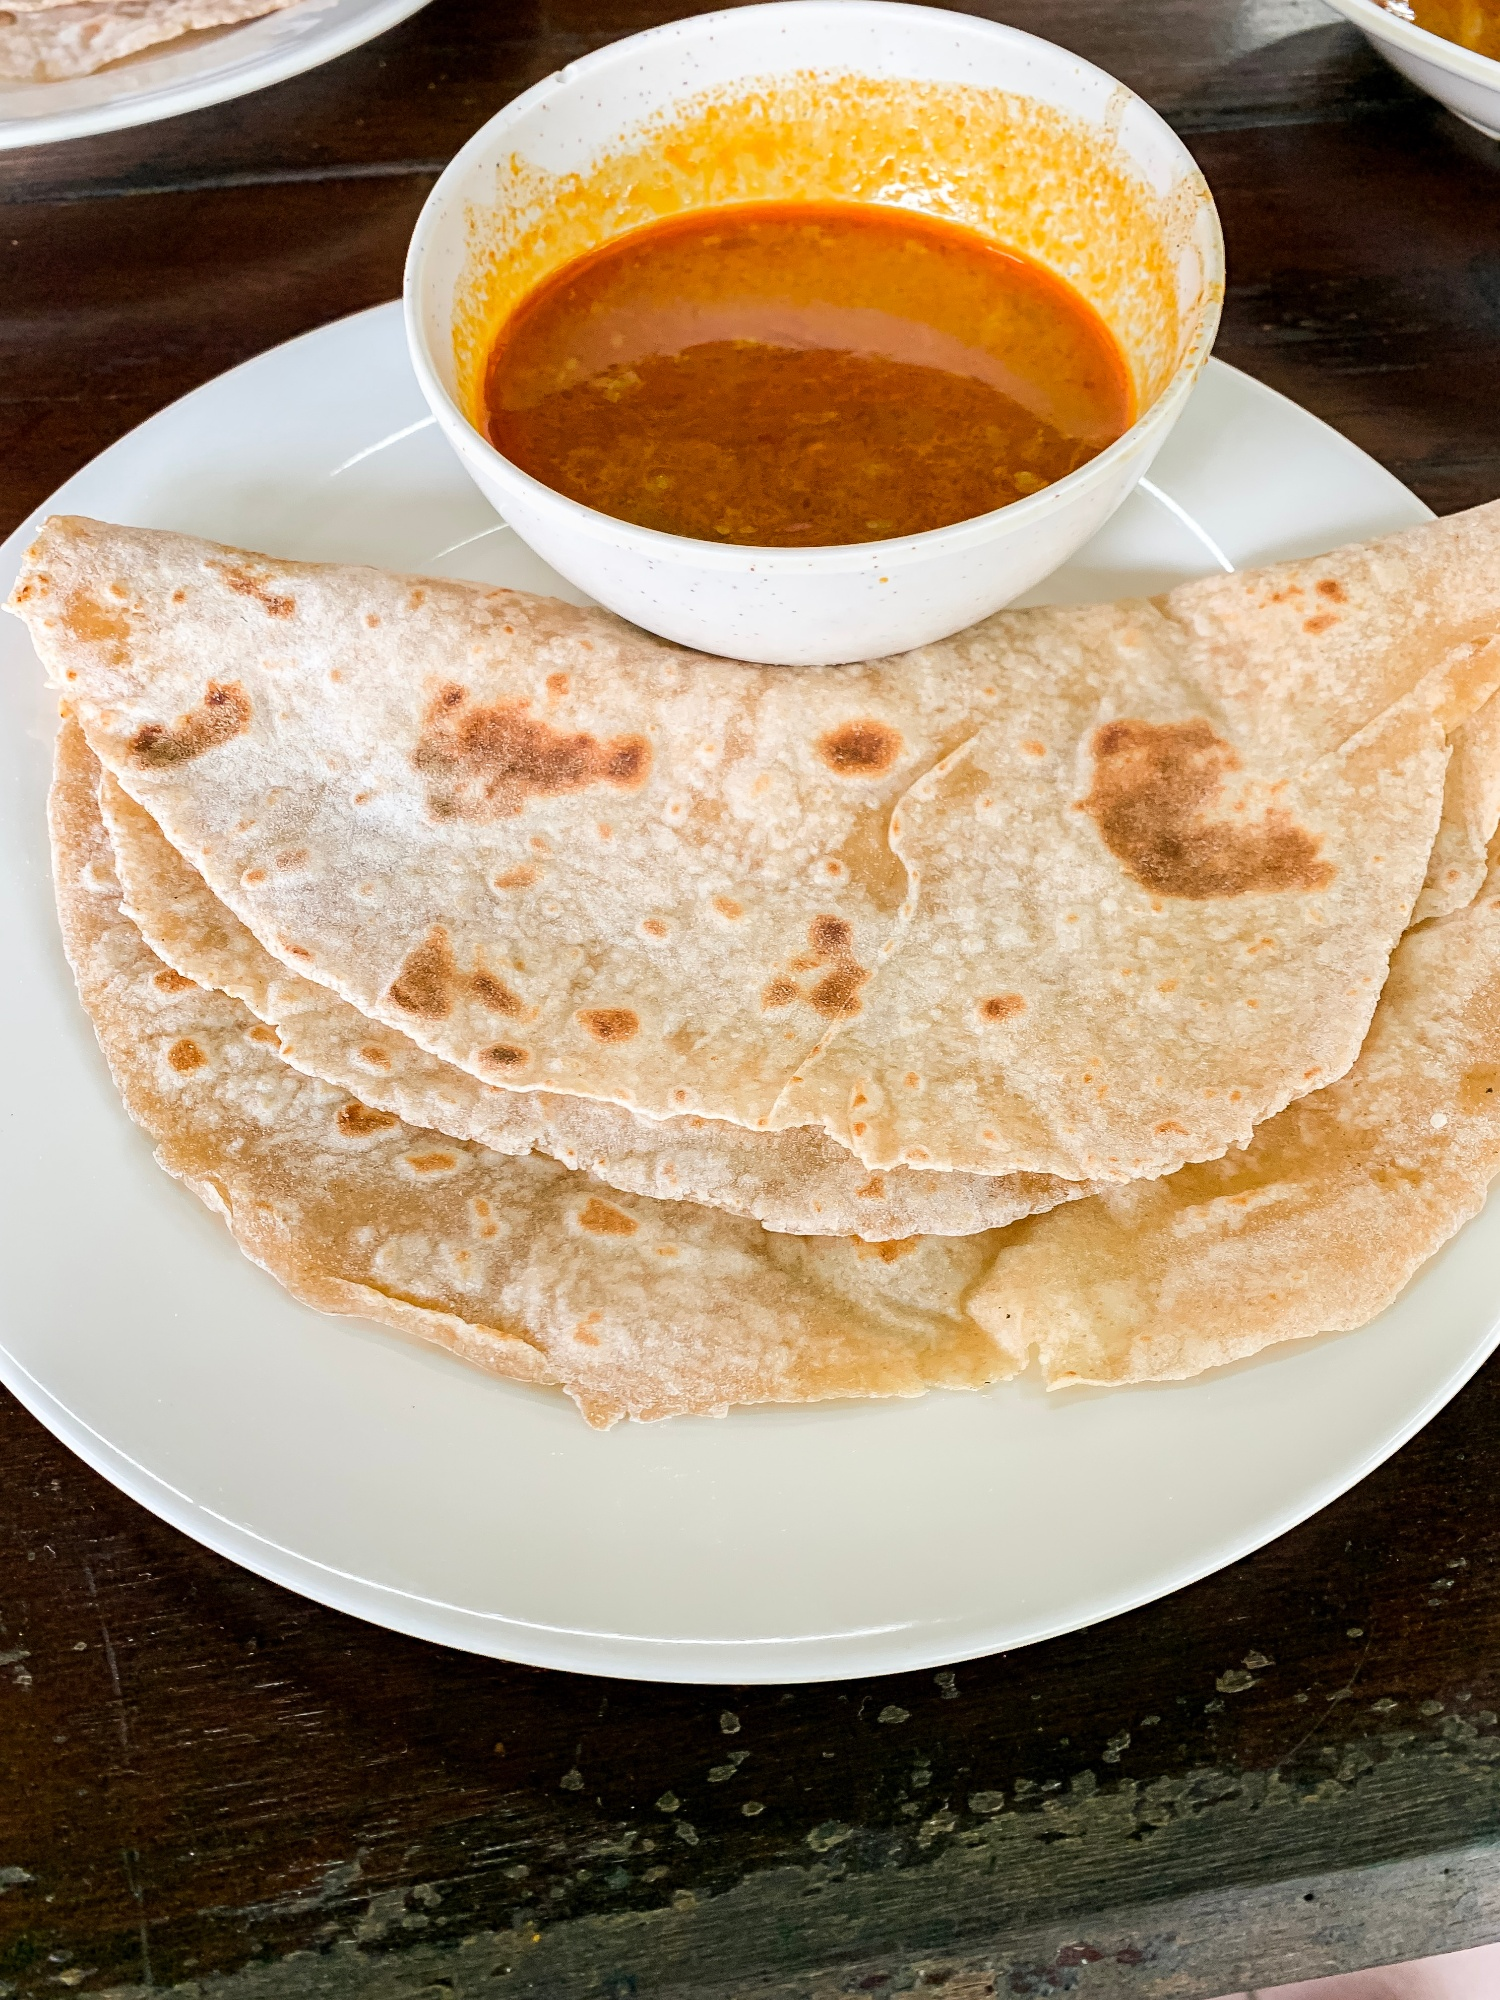Imagine you are describing this meal to someone who has never seen Indian food before. What would you say? Imagine a soft, round bread known as roti, similar in texture to a tortilla but made from whole wheat flour. It's versatile and slightly chewy, perfect for dipping. Alongside it is a bowl of curry, a vibrant and aromatic dish bursting with rich, deep-orange sauce. The curry may contain vegetables, lentils, or meat, and its flavors are a symphony of spices like cumin, coriander, turmeric, and chili—a delightful mix of warmth and heat. This meal is a staple in Indian cuisine, enjoyed by millions daily for its simplicity, nutrition, and comforting taste. What kind of curry do you think it is, based on the color and appearance, and how is it typically made? Based on the vibrant orange color and creamy appearance, this curry could be a classic Indian curry like Chicken Curry, Paneer Butter Masala, or a Lentil Curry (Dal). These curries typically start with sautéing onions, garlic, and ginger in oil or ghee until golden brown. Then, tomatoes and a blend of spices—such as turmeric, cumin, coriander, garam masala, and red chili powder—are added to create a thick, flavorful base. Depending on the recipe, ingredients like chicken, paneer (Indian cottage cheese), or lentils are then incorporated. The curry is simmered until the flavors meld together beautifully, often finished with a touch of cream or yogurt to enhance its richness and texture. The result is a hearty and flavorful dish that pairs perfectly with roti. 